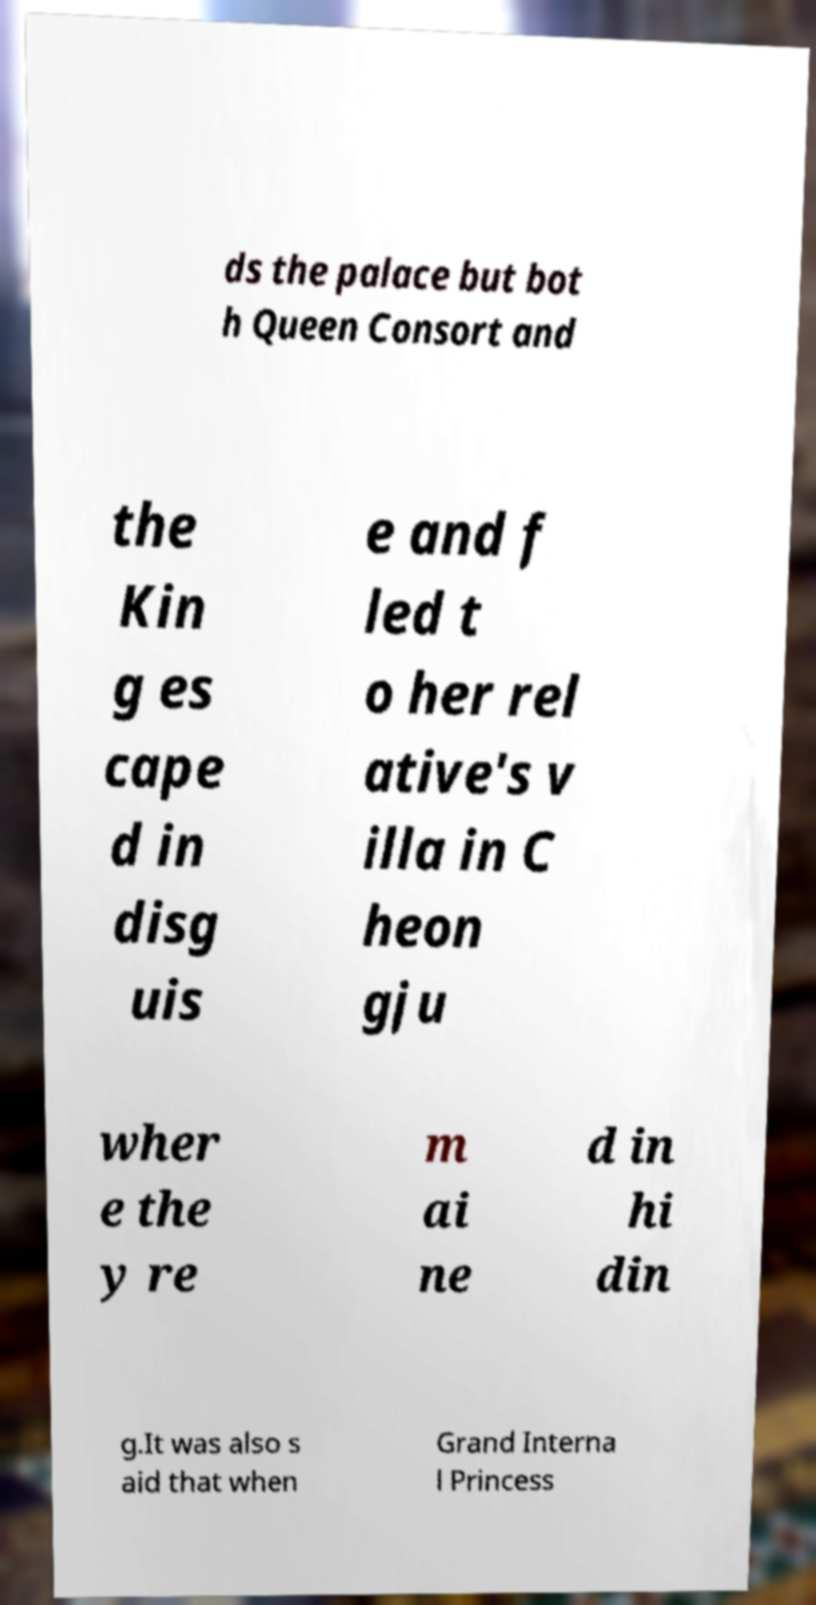What messages or text are displayed in this image? I need them in a readable, typed format. ds the palace but bot h Queen Consort and the Kin g es cape d in disg uis e and f led t o her rel ative's v illa in C heon gju wher e the y re m ai ne d in hi din g.It was also s aid that when Grand Interna l Princess 